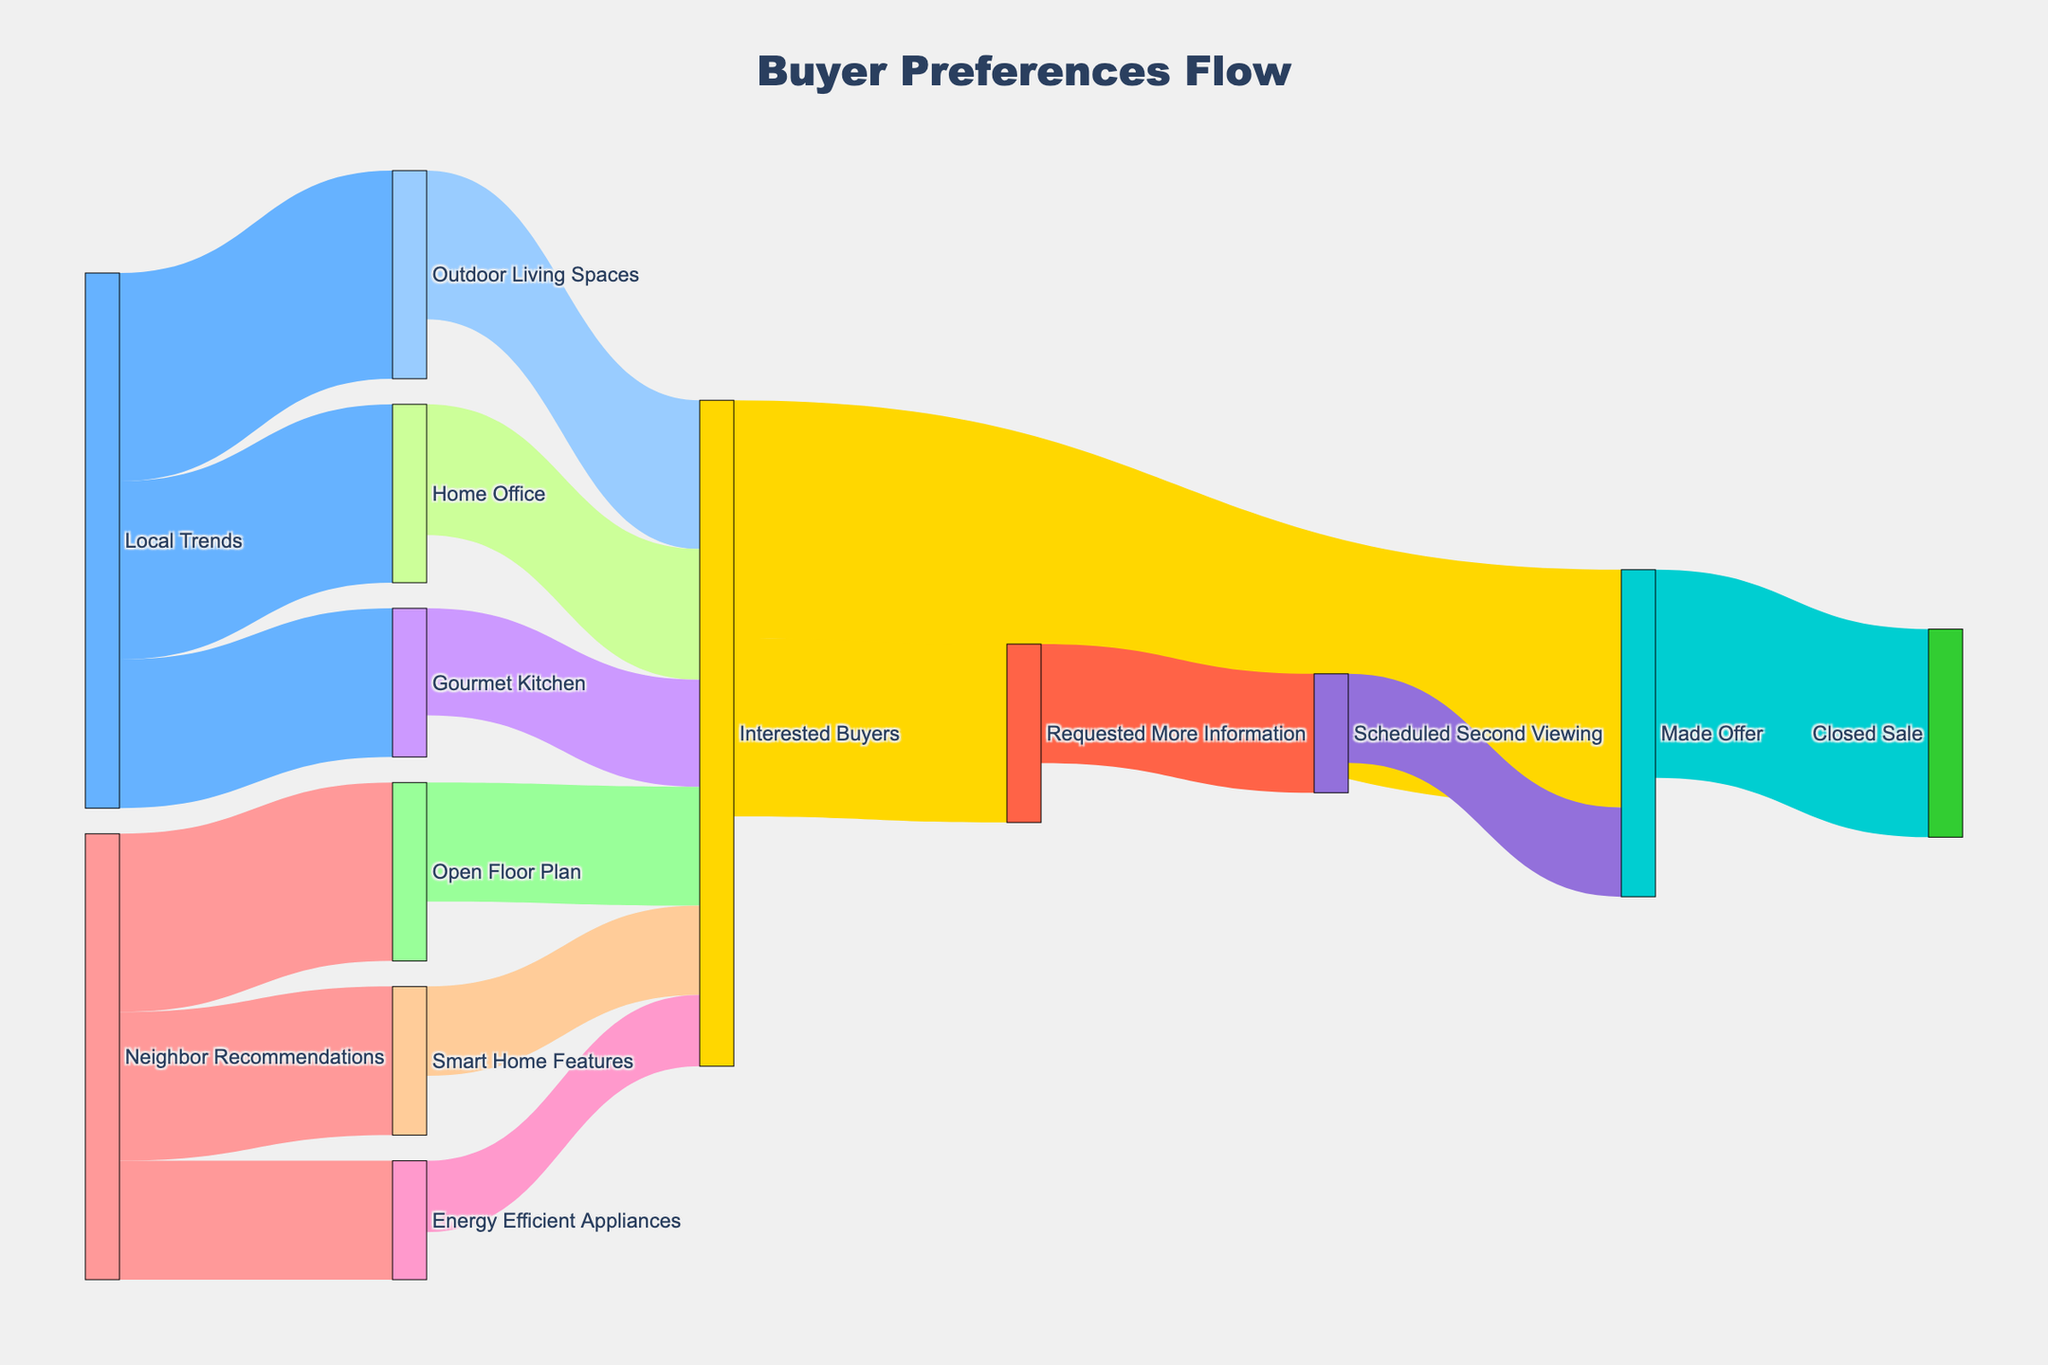What's the title of the figure? The title is displayed at the top of the figure and is labeled "Buyer Preferences Flow" in a large font.
Answer: Buyer Preferences Flow What are the two sources of recommendations shown in the Sankey Diagram? The diagram shows two sources indicated as starting points for flows: "Neighbor Recommendations" and "Local Trends".
Answer: Neighbor Recommendations and Local Trends Which feature, influenced by local trends, received the most interest from buyers? To determine this, look for the feature flow from "Local Trends" with the highest number leading to "Interested Buyers". The "Outdoor Living Spaces" features received the most interest with a value of 25.
Answer: Outdoor Living Spaces How many interested buyers eventually made an offer? Track the flow from "Interested Buyers" to "Made Offer". The figure shows that 40 interested buyers made an offer.
Answer: 40 What is the combined total value of buyers interested in home offices and gourmet kitchens? Add the values of buyers interested in both "Home Office" (22) and "Gourmet Kitchen" (18). So, 22 + 18 = 40.
Answer: 40 Which type of recommendation has a stronger influence on buyer decisions, neighbor recommendations or local trends? Compare the sum of values flowing from each recommendation source to "Interested Buyers". From "Neighbor Recommendations": 20 (Open Floor Plan) + 15 (Smart Home Features) + 12 (Energy Efficient Appliances) = 47. From "Local Trends": 25 (Outdoor Living Spaces) + 22 (Home Office) + 18 (Gourmet Kitchen) = 65. Local trends have a stronger influence.
Answer: Local Trends If you combine all the features recommended by neighbors, what is their total value? Sum the values flowing from "Neighbor Recommendations". 30 (Open Floor Plan) + 25 (Smart Home Features) + 20 (Energy Efficient Appliances) = 75.
Answer: 75 How many interested buyers requested more information instead of making an immediate offer? From "Interested Buyers", the flows show 40 made an offer and 30 requested more information. The number who requested more information is indicated as 30.
Answer: 30 How much higher is the number of interested buyers for an open floor plan compared to those who are interested in energy-efficient appliances? Subtract the value of "Energy Efficient Appliances" (12) from "Open Floor Plan" (20). So, 20 - 12 = 8.
Answer: 8 Who closed more sales: those who made an offer directly or those who scheduled a second viewing? Compare the flows: "Made Offer" directly closed sales with a value of 35. Those who scheduled a second viewing (20) and then made an offer (15) imply the latter closed 15 sales. 35 is higher than 15.
Answer: Those who made an offer directly 